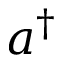Convert formula to latex. <formula><loc_0><loc_0><loc_500><loc_500>a ^ { \dagger }</formula> 